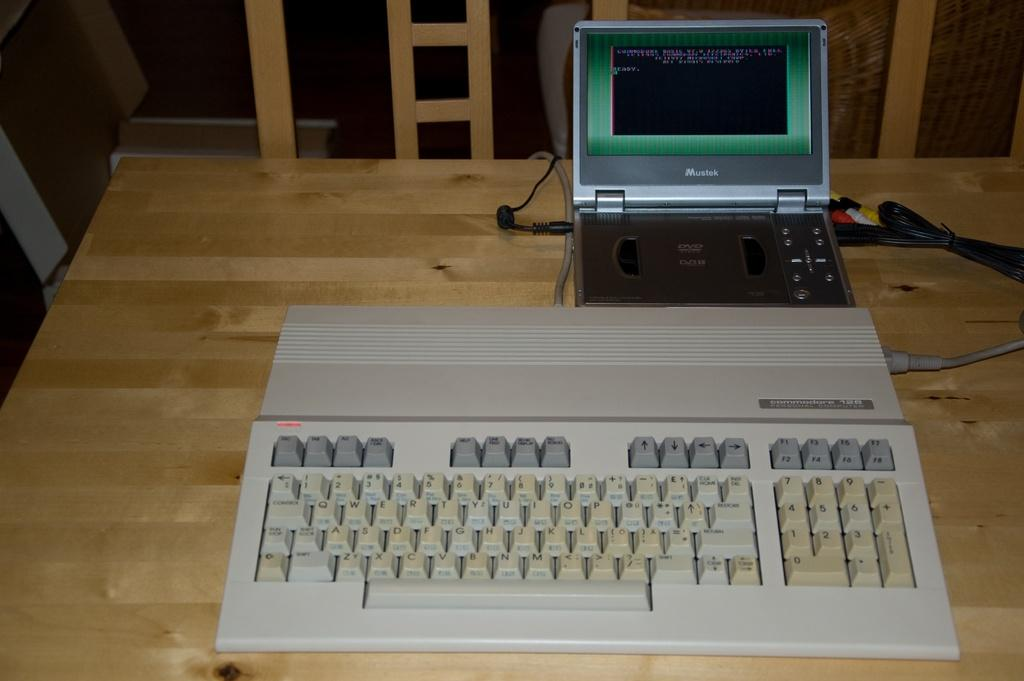Provide a one-sentence caption for the provided image. An old Commodore 128 computer is on a wooden table with a Mustek device connected to it. 